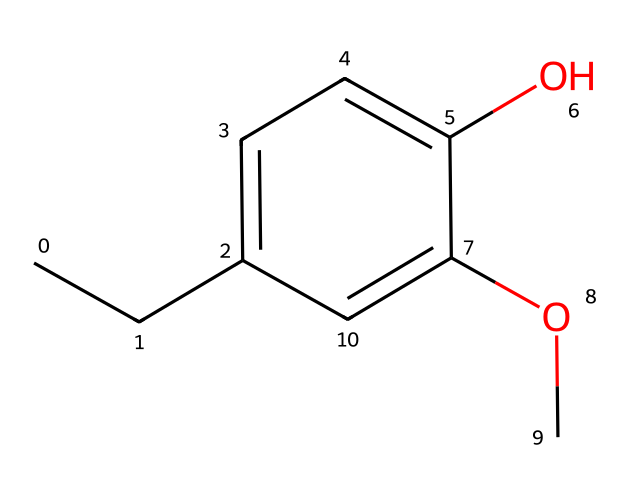What is the molecular formula of eugenol? To find the molecular formula, we count the different types of atoms in the chemical structure. In the SMILES representation, there are 10 carbon (C) atoms, 12 hydrogen (H) atoms, and 3 oxygen (O) atoms. Combining these gives the formula: C10H12O3.
Answer: C10H12O3 How many hydroxyl groups are present in eugenol? A hydroxyl group is represented by -OH in the structure. By inspecting the SMILES, we can see one -OH group attached to the aromatic ring, indicating that there is one hydroxyl group present in eugenol.
Answer: one What type of chemical bond primarily connects the carbon atoms in eugenol? The bonds connecting the carbon atoms in eugenol are primarily single covalent bonds, which can also include one double bond observed in the aromatic ring. Hence, the predominant bond type connecting the carbon atoms is single covalent bonds.
Answer: single covalent bonds Why does eugenol have a phenolic structure? Eugenol contains a hydroxyl (-OH) group attached to a benzene ring, which is the defining characteristic of phenolic compounds. The presence of this -OH group directly bonded to the aromatic ring classifies it as a phenol.
Answer: phenolic compound Which functional group indicates that eugenol is an ether? In the SMILES representation, the -O- group (indicating an ether) is seen between two carbon chains, confirming that eugenol contains an ether functional group. This functional group is responsible for its classification as an ether.
Answer: ether What is the significance of the methoxy group in eugenol? The methoxy group (-OCH3) increases eugenol's lipophilicity and contributes to its overall aromatic nature, which enhances its effectiveness in marine adhesives. This functional group facilitates interactions with other components in adhesive formulations.
Answer: increases lipophilicity 